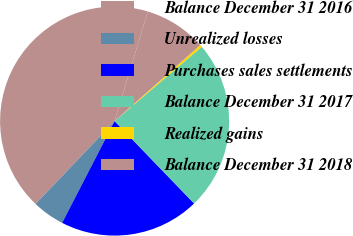Convert chart. <chart><loc_0><loc_0><loc_500><loc_500><pie_chart><fcel>Balance December 31 2016<fcel>Unrealized losses<fcel>Purchases sales settlements<fcel>Balance December 31 2017<fcel>Realized gains<fcel>Balance December 31 2018<nl><fcel>42.55%<fcel>4.55%<fcel>19.79%<fcel>24.01%<fcel>0.33%<fcel>8.77%<nl></chart> 